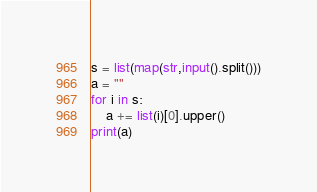<code> <loc_0><loc_0><loc_500><loc_500><_Python_>s = list(map(str,input().split()))
a = ""
for i in s:
    a += list(i)[0].upper()
print(a)

</code> 